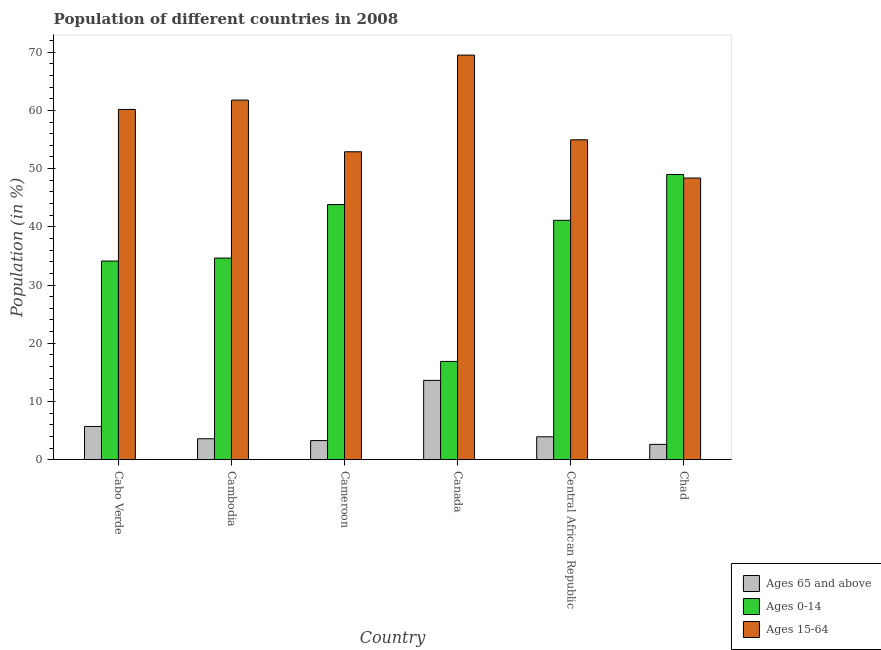How many groups of bars are there?
Offer a terse response. 6. Are the number of bars per tick equal to the number of legend labels?
Your response must be concise. Yes. Are the number of bars on each tick of the X-axis equal?
Offer a very short reply. Yes. What is the label of the 3rd group of bars from the left?
Provide a short and direct response. Cameroon. What is the percentage of population within the age-group of 65 and above in Central African Republic?
Provide a succinct answer. 3.94. Across all countries, what is the maximum percentage of population within the age-group 15-64?
Provide a short and direct response. 69.5. Across all countries, what is the minimum percentage of population within the age-group 15-64?
Your answer should be compact. 48.38. In which country was the percentage of population within the age-group 15-64 minimum?
Your answer should be very brief. Chad. What is the total percentage of population within the age-group 0-14 in the graph?
Offer a very short reply. 219.57. What is the difference between the percentage of population within the age-group 0-14 in Cabo Verde and that in Cambodia?
Your response must be concise. -0.51. What is the difference between the percentage of population within the age-group 0-14 in Central African Republic and the percentage of population within the age-group of 65 and above in Cameroon?
Offer a very short reply. 37.83. What is the average percentage of population within the age-group 15-64 per country?
Your response must be concise. 57.94. What is the difference between the percentage of population within the age-group 15-64 and percentage of population within the age-group of 65 and above in Central African Republic?
Offer a very short reply. 51.01. What is the ratio of the percentage of population within the age-group 0-14 in Cambodia to that in Chad?
Your answer should be very brief. 0.71. Is the percentage of population within the age-group 0-14 in Cabo Verde less than that in Chad?
Your answer should be compact. Yes. What is the difference between the highest and the second highest percentage of population within the age-group 0-14?
Keep it short and to the point. 5.16. What is the difference between the highest and the lowest percentage of population within the age-group of 65 and above?
Your answer should be compact. 10.99. What does the 1st bar from the left in Chad represents?
Offer a terse response. Ages 65 and above. What does the 2nd bar from the right in Cambodia represents?
Offer a terse response. Ages 0-14. Is it the case that in every country, the sum of the percentage of population within the age-group of 65 and above and percentage of population within the age-group 0-14 is greater than the percentage of population within the age-group 15-64?
Give a very brief answer. No. How many bars are there?
Your response must be concise. 18. How many countries are there in the graph?
Your answer should be compact. 6. Does the graph contain grids?
Ensure brevity in your answer.  No. Where does the legend appear in the graph?
Make the answer very short. Bottom right. How are the legend labels stacked?
Your answer should be compact. Vertical. What is the title of the graph?
Offer a very short reply. Population of different countries in 2008. What is the label or title of the X-axis?
Offer a very short reply. Country. What is the Population (in %) of Ages 65 and above in Cabo Verde?
Offer a very short reply. 5.71. What is the Population (in %) of Ages 0-14 in Cabo Verde?
Provide a succinct answer. 34.13. What is the Population (in %) of Ages 15-64 in Cabo Verde?
Provide a succinct answer. 60.16. What is the Population (in %) in Ages 65 and above in Cambodia?
Offer a terse response. 3.6. What is the Population (in %) in Ages 0-14 in Cambodia?
Provide a succinct answer. 34.63. What is the Population (in %) in Ages 15-64 in Cambodia?
Keep it short and to the point. 61.77. What is the Population (in %) in Ages 65 and above in Cameroon?
Offer a very short reply. 3.28. What is the Population (in %) in Ages 0-14 in Cameroon?
Offer a terse response. 43.83. What is the Population (in %) in Ages 15-64 in Cameroon?
Provide a succinct answer. 52.89. What is the Population (in %) in Ages 65 and above in Canada?
Provide a short and direct response. 13.62. What is the Population (in %) of Ages 0-14 in Canada?
Your answer should be very brief. 16.88. What is the Population (in %) of Ages 15-64 in Canada?
Provide a succinct answer. 69.5. What is the Population (in %) of Ages 65 and above in Central African Republic?
Offer a terse response. 3.94. What is the Population (in %) of Ages 0-14 in Central African Republic?
Your response must be concise. 41.12. What is the Population (in %) of Ages 15-64 in Central African Republic?
Make the answer very short. 54.95. What is the Population (in %) in Ages 65 and above in Chad?
Provide a short and direct response. 2.63. What is the Population (in %) of Ages 0-14 in Chad?
Give a very brief answer. 48.99. What is the Population (in %) in Ages 15-64 in Chad?
Keep it short and to the point. 48.38. Across all countries, what is the maximum Population (in %) of Ages 65 and above?
Make the answer very short. 13.62. Across all countries, what is the maximum Population (in %) of Ages 0-14?
Your response must be concise. 48.99. Across all countries, what is the maximum Population (in %) of Ages 15-64?
Your response must be concise. 69.5. Across all countries, what is the minimum Population (in %) of Ages 65 and above?
Offer a terse response. 2.63. Across all countries, what is the minimum Population (in %) in Ages 0-14?
Make the answer very short. 16.88. Across all countries, what is the minimum Population (in %) in Ages 15-64?
Offer a very short reply. 48.38. What is the total Population (in %) of Ages 65 and above in the graph?
Keep it short and to the point. 32.78. What is the total Population (in %) of Ages 0-14 in the graph?
Keep it short and to the point. 219.57. What is the total Population (in %) of Ages 15-64 in the graph?
Offer a terse response. 347.65. What is the difference between the Population (in %) of Ages 65 and above in Cabo Verde and that in Cambodia?
Your response must be concise. 2.12. What is the difference between the Population (in %) in Ages 0-14 in Cabo Verde and that in Cambodia?
Offer a very short reply. -0.51. What is the difference between the Population (in %) in Ages 15-64 in Cabo Verde and that in Cambodia?
Offer a very short reply. -1.61. What is the difference between the Population (in %) in Ages 65 and above in Cabo Verde and that in Cameroon?
Ensure brevity in your answer.  2.43. What is the difference between the Population (in %) in Ages 0-14 in Cabo Verde and that in Cameroon?
Give a very brief answer. -9.7. What is the difference between the Population (in %) of Ages 15-64 in Cabo Verde and that in Cameroon?
Make the answer very short. 7.27. What is the difference between the Population (in %) in Ages 65 and above in Cabo Verde and that in Canada?
Keep it short and to the point. -7.91. What is the difference between the Population (in %) of Ages 0-14 in Cabo Verde and that in Canada?
Offer a terse response. 17.24. What is the difference between the Population (in %) of Ages 15-64 in Cabo Verde and that in Canada?
Provide a succinct answer. -9.33. What is the difference between the Population (in %) in Ages 65 and above in Cabo Verde and that in Central African Republic?
Your answer should be very brief. 1.78. What is the difference between the Population (in %) of Ages 0-14 in Cabo Verde and that in Central African Republic?
Your answer should be compact. -6.99. What is the difference between the Population (in %) in Ages 15-64 in Cabo Verde and that in Central African Republic?
Your answer should be compact. 5.21. What is the difference between the Population (in %) in Ages 65 and above in Cabo Verde and that in Chad?
Your answer should be compact. 3.08. What is the difference between the Population (in %) in Ages 0-14 in Cabo Verde and that in Chad?
Keep it short and to the point. -14.86. What is the difference between the Population (in %) in Ages 15-64 in Cabo Verde and that in Chad?
Offer a very short reply. 11.78. What is the difference between the Population (in %) of Ages 65 and above in Cambodia and that in Cameroon?
Your answer should be compact. 0.31. What is the difference between the Population (in %) in Ages 0-14 in Cambodia and that in Cameroon?
Give a very brief answer. -9.19. What is the difference between the Population (in %) in Ages 15-64 in Cambodia and that in Cameroon?
Give a very brief answer. 8.88. What is the difference between the Population (in %) in Ages 65 and above in Cambodia and that in Canada?
Ensure brevity in your answer.  -10.03. What is the difference between the Population (in %) of Ages 0-14 in Cambodia and that in Canada?
Your response must be concise. 17.75. What is the difference between the Population (in %) of Ages 15-64 in Cambodia and that in Canada?
Keep it short and to the point. -7.73. What is the difference between the Population (in %) of Ages 65 and above in Cambodia and that in Central African Republic?
Keep it short and to the point. -0.34. What is the difference between the Population (in %) in Ages 0-14 in Cambodia and that in Central African Republic?
Offer a terse response. -6.48. What is the difference between the Population (in %) of Ages 15-64 in Cambodia and that in Central African Republic?
Your answer should be compact. 6.82. What is the difference between the Population (in %) in Ages 65 and above in Cambodia and that in Chad?
Provide a short and direct response. 0.96. What is the difference between the Population (in %) in Ages 0-14 in Cambodia and that in Chad?
Offer a terse response. -14.35. What is the difference between the Population (in %) of Ages 15-64 in Cambodia and that in Chad?
Offer a terse response. 13.39. What is the difference between the Population (in %) of Ages 65 and above in Cameroon and that in Canada?
Provide a succinct answer. -10.34. What is the difference between the Population (in %) of Ages 0-14 in Cameroon and that in Canada?
Ensure brevity in your answer.  26.94. What is the difference between the Population (in %) in Ages 15-64 in Cameroon and that in Canada?
Your answer should be compact. -16.6. What is the difference between the Population (in %) of Ages 65 and above in Cameroon and that in Central African Republic?
Offer a very short reply. -0.65. What is the difference between the Population (in %) of Ages 0-14 in Cameroon and that in Central African Republic?
Your answer should be very brief. 2.71. What is the difference between the Population (in %) of Ages 15-64 in Cameroon and that in Central African Republic?
Make the answer very short. -2.06. What is the difference between the Population (in %) in Ages 65 and above in Cameroon and that in Chad?
Keep it short and to the point. 0.65. What is the difference between the Population (in %) in Ages 0-14 in Cameroon and that in Chad?
Keep it short and to the point. -5.16. What is the difference between the Population (in %) of Ages 15-64 in Cameroon and that in Chad?
Provide a succinct answer. 4.51. What is the difference between the Population (in %) in Ages 65 and above in Canada and that in Central African Republic?
Provide a succinct answer. 9.69. What is the difference between the Population (in %) of Ages 0-14 in Canada and that in Central African Republic?
Offer a terse response. -24.23. What is the difference between the Population (in %) of Ages 15-64 in Canada and that in Central African Republic?
Your answer should be compact. 14.55. What is the difference between the Population (in %) in Ages 65 and above in Canada and that in Chad?
Your answer should be compact. 10.99. What is the difference between the Population (in %) in Ages 0-14 in Canada and that in Chad?
Offer a very short reply. -32.11. What is the difference between the Population (in %) of Ages 15-64 in Canada and that in Chad?
Offer a very short reply. 21.12. What is the difference between the Population (in %) of Ages 65 and above in Central African Republic and that in Chad?
Provide a short and direct response. 1.3. What is the difference between the Population (in %) in Ages 0-14 in Central African Republic and that in Chad?
Your response must be concise. -7.87. What is the difference between the Population (in %) of Ages 15-64 in Central African Republic and that in Chad?
Make the answer very short. 6.57. What is the difference between the Population (in %) of Ages 65 and above in Cabo Verde and the Population (in %) of Ages 0-14 in Cambodia?
Ensure brevity in your answer.  -28.92. What is the difference between the Population (in %) in Ages 65 and above in Cabo Verde and the Population (in %) in Ages 15-64 in Cambodia?
Provide a succinct answer. -56.06. What is the difference between the Population (in %) in Ages 0-14 in Cabo Verde and the Population (in %) in Ages 15-64 in Cambodia?
Offer a terse response. -27.64. What is the difference between the Population (in %) in Ages 65 and above in Cabo Verde and the Population (in %) in Ages 0-14 in Cameroon?
Ensure brevity in your answer.  -38.11. What is the difference between the Population (in %) of Ages 65 and above in Cabo Verde and the Population (in %) of Ages 15-64 in Cameroon?
Your response must be concise. -47.18. What is the difference between the Population (in %) of Ages 0-14 in Cabo Verde and the Population (in %) of Ages 15-64 in Cameroon?
Your answer should be compact. -18.77. What is the difference between the Population (in %) of Ages 65 and above in Cabo Verde and the Population (in %) of Ages 0-14 in Canada?
Provide a succinct answer. -11.17. What is the difference between the Population (in %) of Ages 65 and above in Cabo Verde and the Population (in %) of Ages 15-64 in Canada?
Your answer should be very brief. -63.78. What is the difference between the Population (in %) in Ages 0-14 in Cabo Verde and the Population (in %) in Ages 15-64 in Canada?
Make the answer very short. -35.37. What is the difference between the Population (in %) in Ages 65 and above in Cabo Verde and the Population (in %) in Ages 0-14 in Central African Republic?
Keep it short and to the point. -35.41. What is the difference between the Population (in %) in Ages 65 and above in Cabo Verde and the Population (in %) in Ages 15-64 in Central African Republic?
Offer a terse response. -49.24. What is the difference between the Population (in %) in Ages 0-14 in Cabo Verde and the Population (in %) in Ages 15-64 in Central African Republic?
Provide a short and direct response. -20.82. What is the difference between the Population (in %) of Ages 65 and above in Cabo Verde and the Population (in %) of Ages 0-14 in Chad?
Keep it short and to the point. -43.28. What is the difference between the Population (in %) in Ages 65 and above in Cabo Verde and the Population (in %) in Ages 15-64 in Chad?
Make the answer very short. -42.67. What is the difference between the Population (in %) of Ages 0-14 in Cabo Verde and the Population (in %) of Ages 15-64 in Chad?
Ensure brevity in your answer.  -14.25. What is the difference between the Population (in %) of Ages 65 and above in Cambodia and the Population (in %) of Ages 0-14 in Cameroon?
Ensure brevity in your answer.  -40.23. What is the difference between the Population (in %) of Ages 65 and above in Cambodia and the Population (in %) of Ages 15-64 in Cameroon?
Your response must be concise. -49.3. What is the difference between the Population (in %) of Ages 0-14 in Cambodia and the Population (in %) of Ages 15-64 in Cameroon?
Offer a very short reply. -18.26. What is the difference between the Population (in %) of Ages 65 and above in Cambodia and the Population (in %) of Ages 0-14 in Canada?
Make the answer very short. -13.29. What is the difference between the Population (in %) in Ages 65 and above in Cambodia and the Population (in %) in Ages 15-64 in Canada?
Ensure brevity in your answer.  -65.9. What is the difference between the Population (in %) in Ages 0-14 in Cambodia and the Population (in %) in Ages 15-64 in Canada?
Give a very brief answer. -34.86. What is the difference between the Population (in %) in Ages 65 and above in Cambodia and the Population (in %) in Ages 0-14 in Central African Republic?
Your answer should be very brief. -37.52. What is the difference between the Population (in %) in Ages 65 and above in Cambodia and the Population (in %) in Ages 15-64 in Central African Republic?
Your response must be concise. -51.35. What is the difference between the Population (in %) of Ages 0-14 in Cambodia and the Population (in %) of Ages 15-64 in Central African Republic?
Give a very brief answer. -20.31. What is the difference between the Population (in %) in Ages 65 and above in Cambodia and the Population (in %) in Ages 0-14 in Chad?
Provide a short and direct response. -45.39. What is the difference between the Population (in %) of Ages 65 and above in Cambodia and the Population (in %) of Ages 15-64 in Chad?
Offer a terse response. -44.78. What is the difference between the Population (in %) of Ages 0-14 in Cambodia and the Population (in %) of Ages 15-64 in Chad?
Ensure brevity in your answer.  -13.74. What is the difference between the Population (in %) in Ages 65 and above in Cameroon and the Population (in %) in Ages 0-14 in Canada?
Offer a terse response. -13.6. What is the difference between the Population (in %) in Ages 65 and above in Cameroon and the Population (in %) in Ages 15-64 in Canada?
Offer a terse response. -66.21. What is the difference between the Population (in %) in Ages 0-14 in Cameroon and the Population (in %) in Ages 15-64 in Canada?
Provide a short and direct response. -25.67. What is the difference between the Population (in %) in Ages 65 and above in Cameroon and the Population (in %) in Ages 0-14 in Central African Republic?
Your answer should be compact. -37.83. What is the difference between the Population (in %) in Ages 65 and above in Cameroon and the Population (in %) in Ages 15-64 in Central African Republic?
Offer a terse response. -51.67. What is the difference between the Population (in %) of Ages 0-14 in Cameroon and the Population (in %) of Ages 15-64 in Central African Republic?
Keep it short and to the point. -11.12. What is the difference between the Population (in %) of Ages 65 and above in Cameroon and the Population (in %) of Ages 0-14 in Chad?
Your response must be concise. -45.71. What is the difference between the Population (in %) in Ages 65 and above in Cameroon and the Population (in %) in Ages 15-64 in Chad?
Make the answer very short. -45.1. What is the difference between the Population (in %) of Ages 0-14 in Cameroon and the Population (in %) of Ages 15-64 in Chad?
Offer a terse response. -4.55. What is the difference between the Population (in %) in Ages 65 and above in Canada and the Population (in %) in Ages 0-14 in Central African Republic?
Provide a short and direct response. -27.49. What is the difference between the Population (in %) in Ages 65 and above in Canada and the Population (in %) in Ages 15-64 in Central African Republic?
Provide a short and direct response. -41.33. What is the difference between the Population (in %) in Ages 0-14 in Canada and the Population (in %) in Ages 15-64 in Central African Republic?
Offer a terse response. -38.07. What is the difference between the Population (in %) in Ages 65 and above in Canada and the Population (in %) in Ages 0-14 in Chad?
Make the answer very short. -35.36. What is the difference between the Population (in %) of Ages 65 and above in Canada and the Population (in %) of Ages 15-64 in Chad?
Your response must be concise. -34.76. What is the difference between the Population (in %) of Ages 0-14 in Canada and the Population (in %) of Ages 15-64 in Chad?
Ensure brevity in your answer.  -31.5. What is the difference between the Population (in %) in Ages 65 and above in Central African Republic and the Population (in %) in Ages 0-14 in Chad?
Your answer should be very brief. -45.05. What is the difference between the Population (in %) in Ages 65 and above in Central African Republic and the Population (in %) in Ages 15-64 in Chad?
Give a very brief answer. -44.44. What is the difference between the Population (in %) in Ages 0-14 in Central African Republic and the Population (in %) in Ages 15-64 in Chad?
Your answer should be compact. -7.26. What is the average Population (in %) of Ages 65 and above per country?
Your response must be concise. 5.46. What is the average Population (in %) in Ages 0-14 per country?
Your answer should be very brief. 36.6. What is the average Population (in %) in Ages 15-64 per country?
Give a very brief answer. 57.94. What is the difference between the Population (in %) in Ages 65 and above and Population (in %) in Ages 0-14 in Cabo Verde?
Provide a short and direct response. -28.41. What is the difference between the Population (in %) in Ages 65 and above and Population (in %) in Ages 15-64 in Cabo Verde?
Make the answer very short. -54.45. What is the difference between the Population (in %) in Ages 0-14 and Population (in %) in Ages 15-64 in Cabo Verde?
Your answer should be compact. -26.04. What is the difference between the Population (in %) of Ages 65 and above and Population (in %) of Ages 0-14 in Cambodia?
Make the answer very short. -31.04. What is the difference between the Population (in %) of Ages 65 and above and Population (in %) of Ages 15-64 in Cambodia?
Provide a short and direct response. -58.17. What is the difference between the Population (in %) of Ages 0-14 and Population (in %) of Ages 15-64 in Cambodia?
Provide a succinct answer. -27.14. What is the difference between the Population (in %) in Ages 65 and above and Population (in %) in Ages 0-14 in Cameroon?
Your response must be concise. -40.54. What is the difference between the Population (in %) of Ages 65 and above and Population (in %) of Ages 15-64 in Cameroon?
Your answer should be compact. -49.61. What is the difference between the Population (in %) of Ages 0-14 and Population (in %) of Ages 15-64 in Cameroon?
Ensure brevity in your answer.  -9.07. What is the difference between the Population (in %) in Ages 65 and above and Population (in %) in Ages 0-14 in Canada?
Your answer should be compact. -3.26. What is the difference between the Population (in %) in Ages 65 and above and Population (in %) in Ages 15-64 in Canada?
Make the answer very short. -55.87. What is the difference between the Population (in %) of Ages 0-14 and Population (in %) of Ages 15-64 in Canada?
Give a very brief answer. -52.61. What is the difference between the Population (in %) in Ages 65 and above and Population (in %) in Ages 0-14 in Central African Republic?
Provide a short and direct response. -37.18. What is the difference between the Population (in %) of Ages 65 and above and Population (in %) of Ages 15-64 in Central African Republic?
Provide a succinct answer. -51.01. What is the difference between the Population (in %) in Ages 0-14 and Population (in %) in Ages 15-64 in Central African Republic?
Your answer should be compact. -13.83. What is the difference between the Population (in %) in Ages 65 and above and Population (in %) in Ages 0-14 in Chad?
Provide a short and direct response. -46.35. What is the difference between the Population (in %) in Ages 65 and above and Population (in %) in Ages 15-64 in Chad?
Your answer should be very brief. -45.75. What is the difference between the Population (in %) of Ages 0-14 and Population (in %) of Ages 15-64 in Chad?
Your answer should be compact. 0.61. What is the ratio of the Population (in %) in Ages 65 and above in Cabo Verde to that in Cambodia?
Ensure brevity in your answer.  1.59. What is the ratio of the Population (in %) of Ages 15-64 in Cabo Verde to that in Cambodia?
Keep it short and to the point. 0.97. What is the ratio of the Population (in %) of Ages 65 and above in Cabo Verde to that in Cameroon?
Provide a succinct answer. 1.74. What is the ratio of the Population (in %) in Ages 0-14 in Cabo Verde to that in Cameroon?
Ensure brevity in your answer.  0.78. What is the ratio of the Population (in %) in Ages 15-64 in Cabo Verde to that in Cameroon?
Your answer should be compact. 1.14. What is the ratio of the Population (in %) in Ages 65 and above in Cabo Verde to that in Canada?
Provide a short and direct response. 0.42. What is the ratio of the Population (in %) of Ages 0-14 in Cabo Verde to that in Canada?
Your answer should be very brief. 2.02. What is the ratio of the Population (in %) of Ages 15-64 in Cabo Verde to that in Canada?
Provide a succinct answer. 0.87. What is the ratio of the Population (in %) in Ages 65 and above in Cabo Verde to that in Central African Republic?
Provide a succinct answer. 1.45. What is the ratio of the Population (in %) of Ages 0-14 in Cabo Verde to that in Central African Republic?
Your response must be concise. 0.83. What is the ratio of the Population (in %) in Ages 15-64 in Cabo Verde to that in Central African Republic?
Your answer should be compact. 1.09. What is the ratio of the Population (in %) in Ages 65 and above in Cabo Verde to that in Chad?
Provide a short and direct response. 2.17. What is the ratio of the Population (in %) in Ages 0-14 in Cabo Verde to that in Chad?
Your answer should be compact. 0.7. What is the ratio of the Population (in %) of Ages 15-64 in Cabo Verde to that in Chad?
Provide a short and direct response. 1.24. What is the ratio of the Population (in %) of Ages 65 and above in Cambodia to that in Cameroon?
Your answer should be very brief. 1.1. What is the ratio of the Population (in %) in Ages 0-14 in Cambodia to that in Cameroon?
Your answer should be very brief. 0.79. What is the ratio of the Population (in %) of Ages 15-64 in Cambodia to that in Cameroon?
Offer a very short reply. 1.17. What is the ratio of the Population (in %) in Ages 65 and above in Cambodia to that in Canada?
Provide a succinct answer. 0.26. What is the ratio of the Population (in %) of Ages 0-14 in Cambodia to that in Canada?
Your answer should be compact. 2.05. What is the ratio of the Population (in %) in Ages 15-64 in Cambodia to that in Canada?
Keep it short and to the point. 0.89. What is the ratio of the Population (in %) in Ages 65 and above in Cambodia to that in Central African Republic?
Your response must be concise. 0.91. What is the ratio of the Population (in %) in Ages 0-14 in Cambodia to that in Central African Republic?
Offer a terse response. 0.84. What is the ratio of the Population (in %) of Ages 15-64 in Cambodia to that in Central African Republic?
Your answer should be compact. 1.12. What is the ratio of the Population (in %) in Ages 65 and above in Cambodia to that in Chad?
Ensure brevity in your answer.  1.37. What is the ratio of the Population (in %) in Ages 0-14 in Cambodia to that in Chad?
Provide a succinct answer. 0.71. What is the ratio of the Population (in %) in Ages 15-64 in Cambodia to that in Chad?
Give a very brief answer. 1.28. What is the ratio of the Population (in %) in Ages 65 and above in Cameroon to that in Canada?
Give a very brief answer. 0.24. What is the ratio of the Population (in %) of Ages 0-14 in Cameroon to that in Canada?
Your answer should be very brief. 2.6. What is the ratio of the Population (in %) in Ages 15-64 in Cameroon to that in Canada?
Make the answer very short. 0.76. What is the ratio of the Population (in %) of Ages 65 and above in Cameroon to that in Central African Republic?
Keep it short and to the point. 0.83. What is the ratio of the Population (in %) in Ages 0-14 in Cameroon to that in Central African Republic?
Make the answer very short. 1.07. What is the ratio of the Population (in %) in Ages 15-64 in Cameroon to that in Central African Republic?
Your answer should be very brief. 0.96. What is the ratio of the Population (in %) of Ages 65 and above in Cameroon to that in Chad?
Ensure brevity in your answer.  1.25. What is the ratio of the Population (in %) in Ages 0-14 in Cameroon to that in Chad?
Keep it short and to the point. 0.89. What is the ratio of the Population (in %) of Ages 15-64 in Cameroon to that in Chad?
Provide a succinct answer. 1.09. What is the ratio of the Population (in %) in Ages 65 and above in Canada to that in Central African Republic?
Your answer should be very brief. 3.46. What is the ratio of the Population (in %) in Ages 0-14 in Canada to that in Central African Republic?
Ensure brevity in your answer.  0.41. What is the ratio of the Population (in %) of Ages 15-64 in Canada to that in Central African Republic?
Offer a terse response. 1.26. What is the ratio of the Population (in %) in Ages 65 and above in Canada to that in Chad?
Your answer should be compact. 5.17. What is the ratio of the Population (in %) in Ages 0-14 in Canada to that in Chad?
Your answer should be compact. 0.34. What is the ratio of the Population (in %) of Ages 15-64 in Canada to that in Chad?
Provide a short and direct response. 1.44. What is the ratio of the Population (in %) in Ages 65 and above in Central African Republic to that in Chad?
Offer a terse response. 1.49. What is the ratio of the Population (in %) in Ages 0-14 in Central African Republic to that in Chad?
Keep it short and to the point. 0.84. What is the ratio of the Population (in %) in Ages 15-64 in Central African Republic to that in Chad?
Give a very brief answer. 1.14. What is the difference between the highest and the second highest Population (in %) in Ages 65 and above?
Give a very brief answer. 7.91. What is the difference between the highest and the second highest Population (in %) of Ages 0-14?
Your answer should be very brief. 5.16. What is the difference between the highest and the second highest Population (in %) in Ages 15-64?
Ensure brevity in your answer.  7.73. What is the difference between the highest and the lowest Population (in %) of Ages 65 and above?
Offer a very short reply. 10.99. What is the difference between the highest and the lowest Population (in %) in Ages 0-14?
Your answer should be compact. 32.11. What is the difference between the highest and the lowest Population (in %) in Ages 15-64?
Your answer should be very brief. 21.12. 